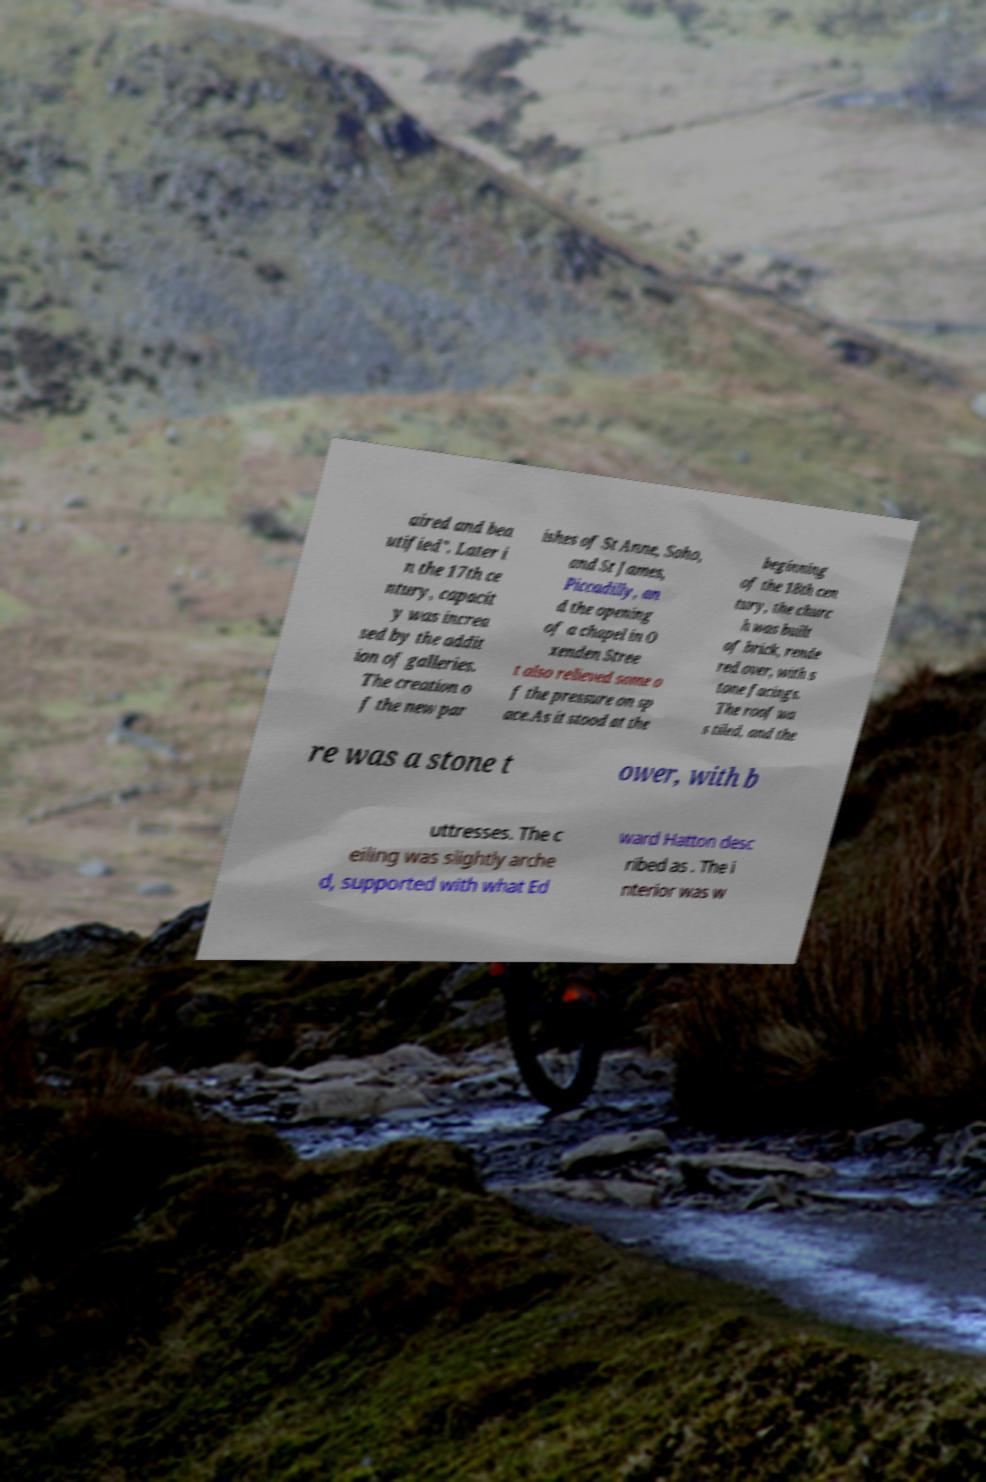There's text embedded in this image that I need extracted. Can you transcribe it verbatim? aired and bea utified". Later i n the 17th ce ntury, capacit y was increa sed by the addit ion of galleries. The creation o f the new par ishes of St Anne, Soho, and St James, Piccadilly, an d the opening of a chapel in O xenden Stree t also relieved some o f the pressure on sp ace.As it stood at the beginning of the 18th cen tury, the churc h was built of brick, rende red over, with s tone facings. The roof wa s tiled, and the re was a stone t ower, with b uttresses. The c eiling was slightly arche d, supported with what Ed ward Hatton desc ribed as . The i nterior was w 